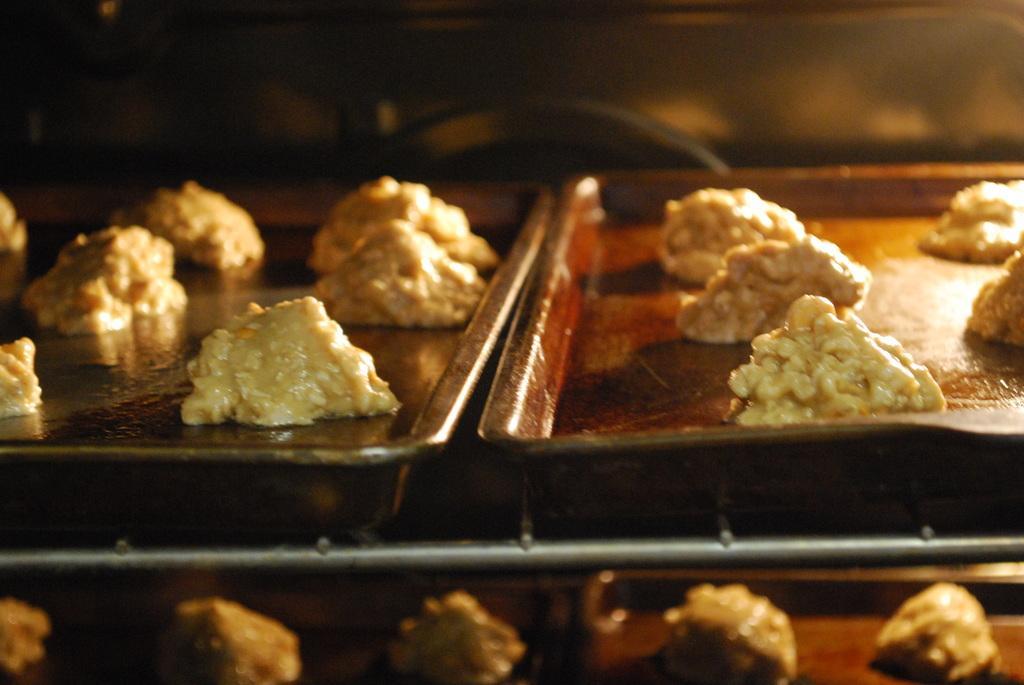Can you describe this image briefly? In this image we can see cookies in a bakery trays. 